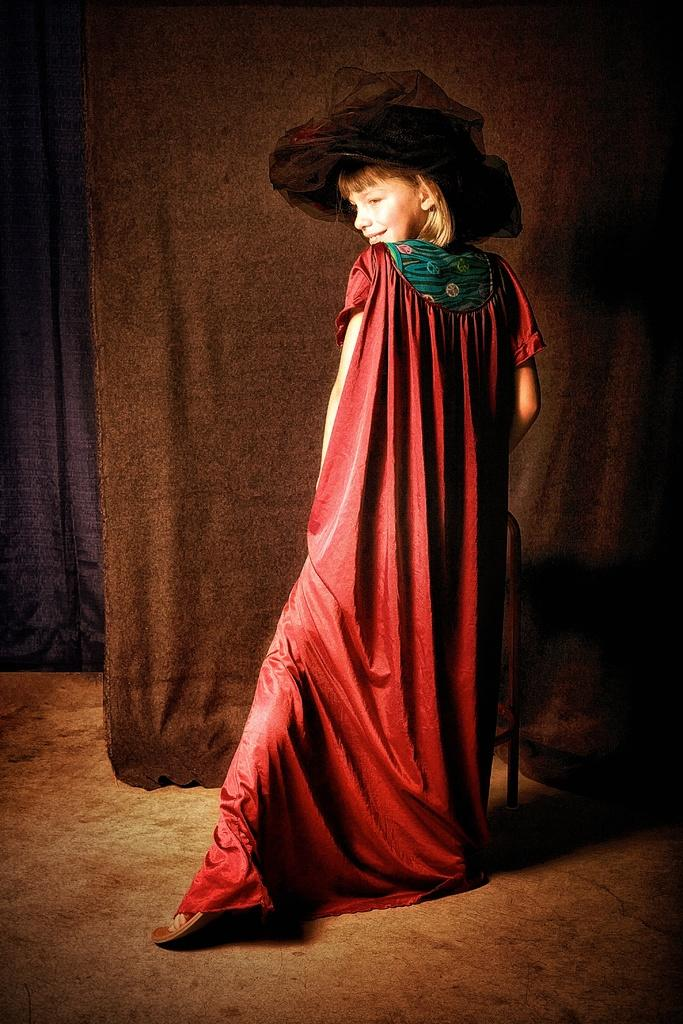Who is the main subject in the image? There is a girl in the image. What is the girl wearing? The girl is wearing a red dress and a black hat. What piece of furniture is present in the image? There is a chair in the image. What type of window treatment can be seen in the image? There are curtains in the image. What type of watch is the girl wearing in the image? The girl is not wearing a watch in the image. What type of support does the girl provide for the cabbage in the image? There is no cabbage present in the image, so no support is provided. 